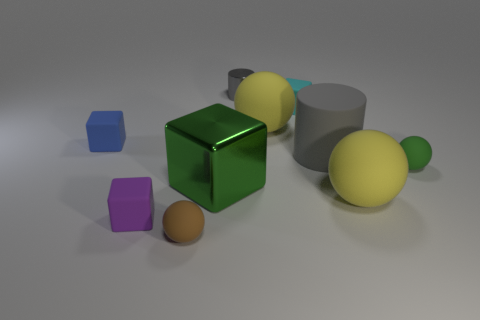Subtract all tiny cubes. How many cubes are left? 1 Subtract all yellow blocks. Subtract all purple cylinders. How many blocks are left? 4 Subtract all cylinders. How many objects are left? 8 Subtract 0 gray cubes. How many objects are left? 10 Subtract all big metallic things. Subtract all rubber cylinders. How many objects are left? 8 Add 4 small blue matte blocks. How many small blue matte blocks are left? 5 Add 6 large brown cubes. How many large brown cubes exist? 6 